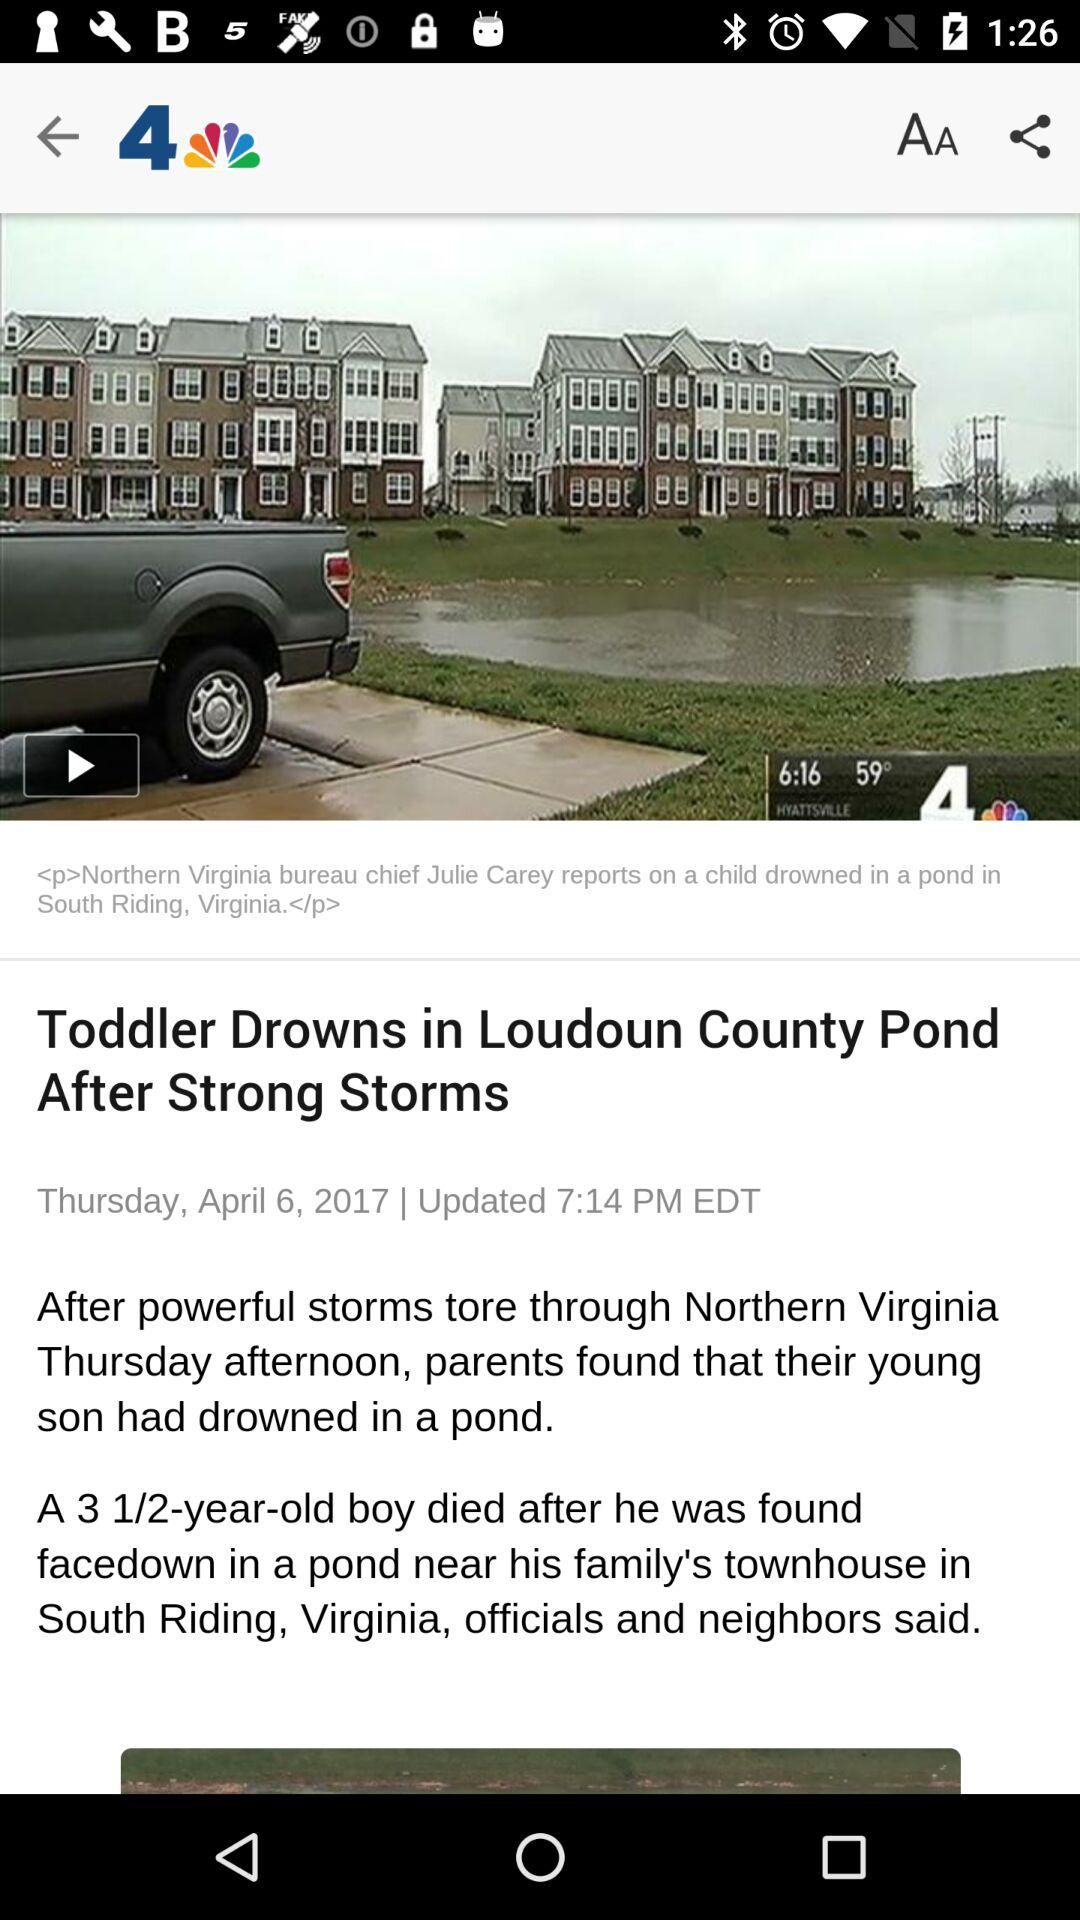What is the day on April 6, 2017? The day is "Thursday". 